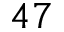Convert formula to latex. <formula><loc_0><loc_0><loc_500><loc_500>4 7</formula> 